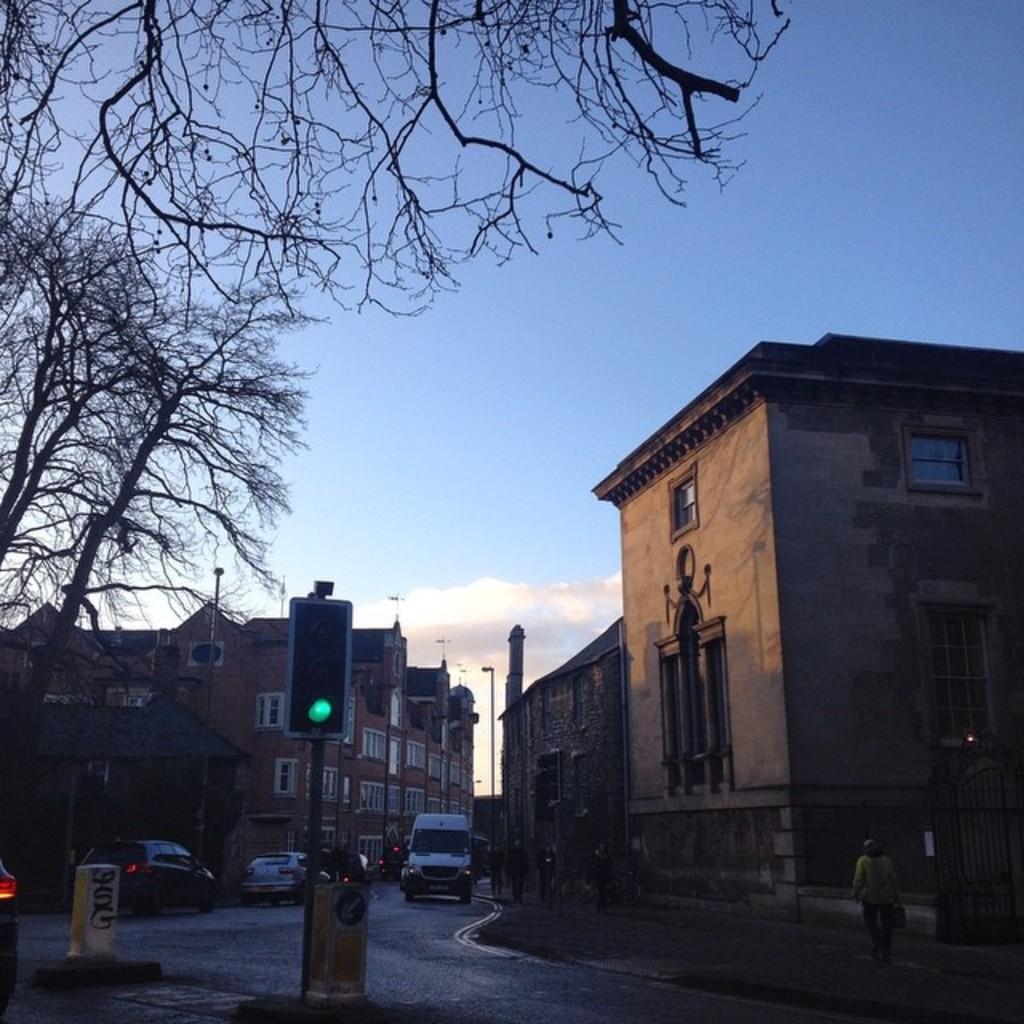Could you give a brief overview of what you see in this image? To the bottom of the image there is a sign board, pole with traffic signal and few other items. In the middle there is a road. On the road there are few vehicles. To the right corner of the image there is a gate and also there is a building with walls, windows and roofs. In front of the building there is a footpath with few people walking. To the left side of the image there are trees and also there are buildings with walls, windows and roofs. To the top of the image there is a sky in the background.  